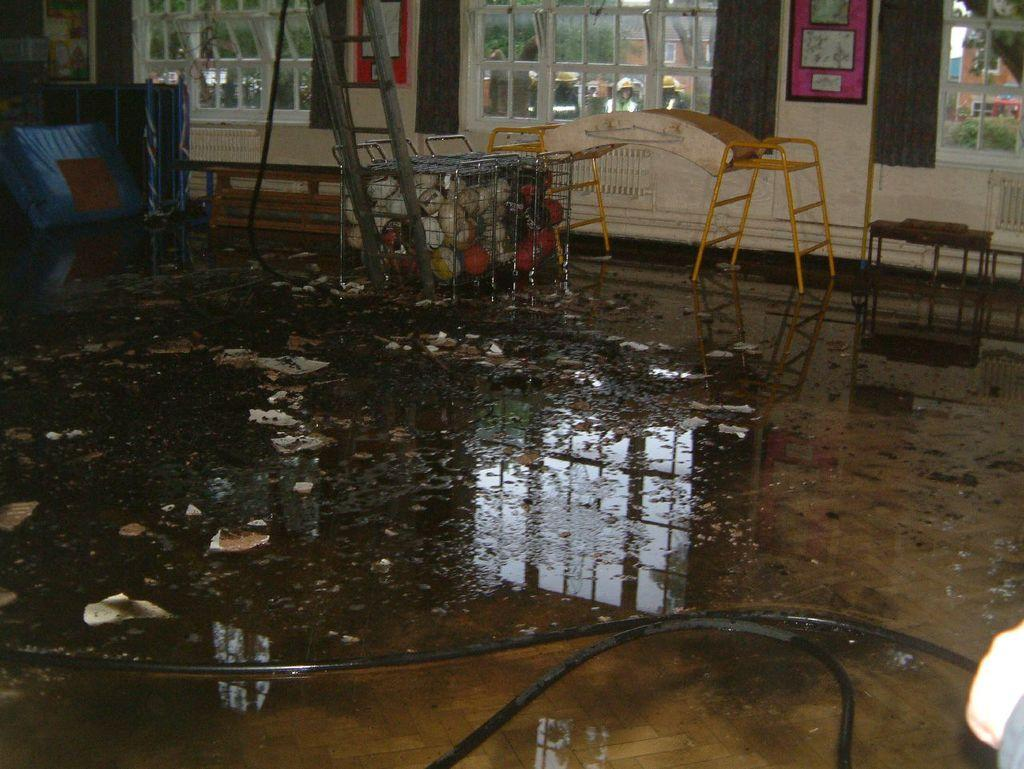What is the primary element visible in the image? There is water in the image. What structures can be seen in the image? There are pipes in the image. What is on the floor in the image? There are objects on the floor in the image. What architectural feature is present in the image? There are windows in the image. What is attached to the wall in the image? There are objects attached to the wall in the image. What decision is being made by the balloon in the image? There is no balloon present in the image, so no decision can be made by a balloon. 